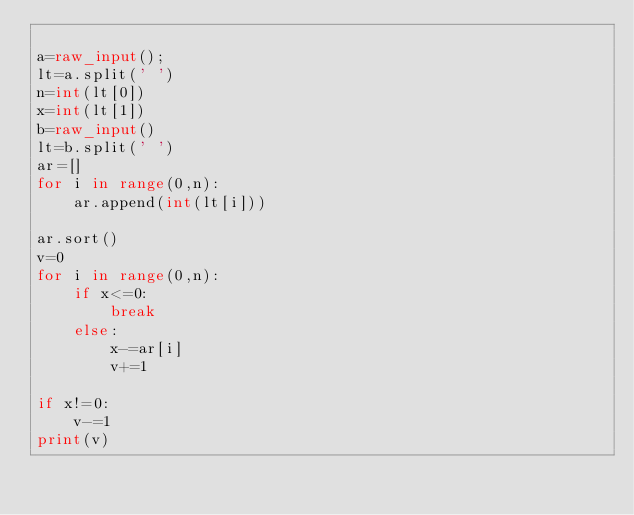<code> <loc_0><loc_0><loc_500><loc_500><_Python_>
a=raw_input();
lt=a.split(' ')
n=int(lt[0])
x=int(lt[1])
b=raw_input()
lt=b.split(' ')
ar=[]
for i in range(0,n):
	ar.append(int(lt[i]))

ar.sort()
v=0
for i in range(0,n):
	if x<=0:
		break
	else:
		x-=ar[i]
		v+=1

if x!=0:
	v-=1
print(v)</code> 